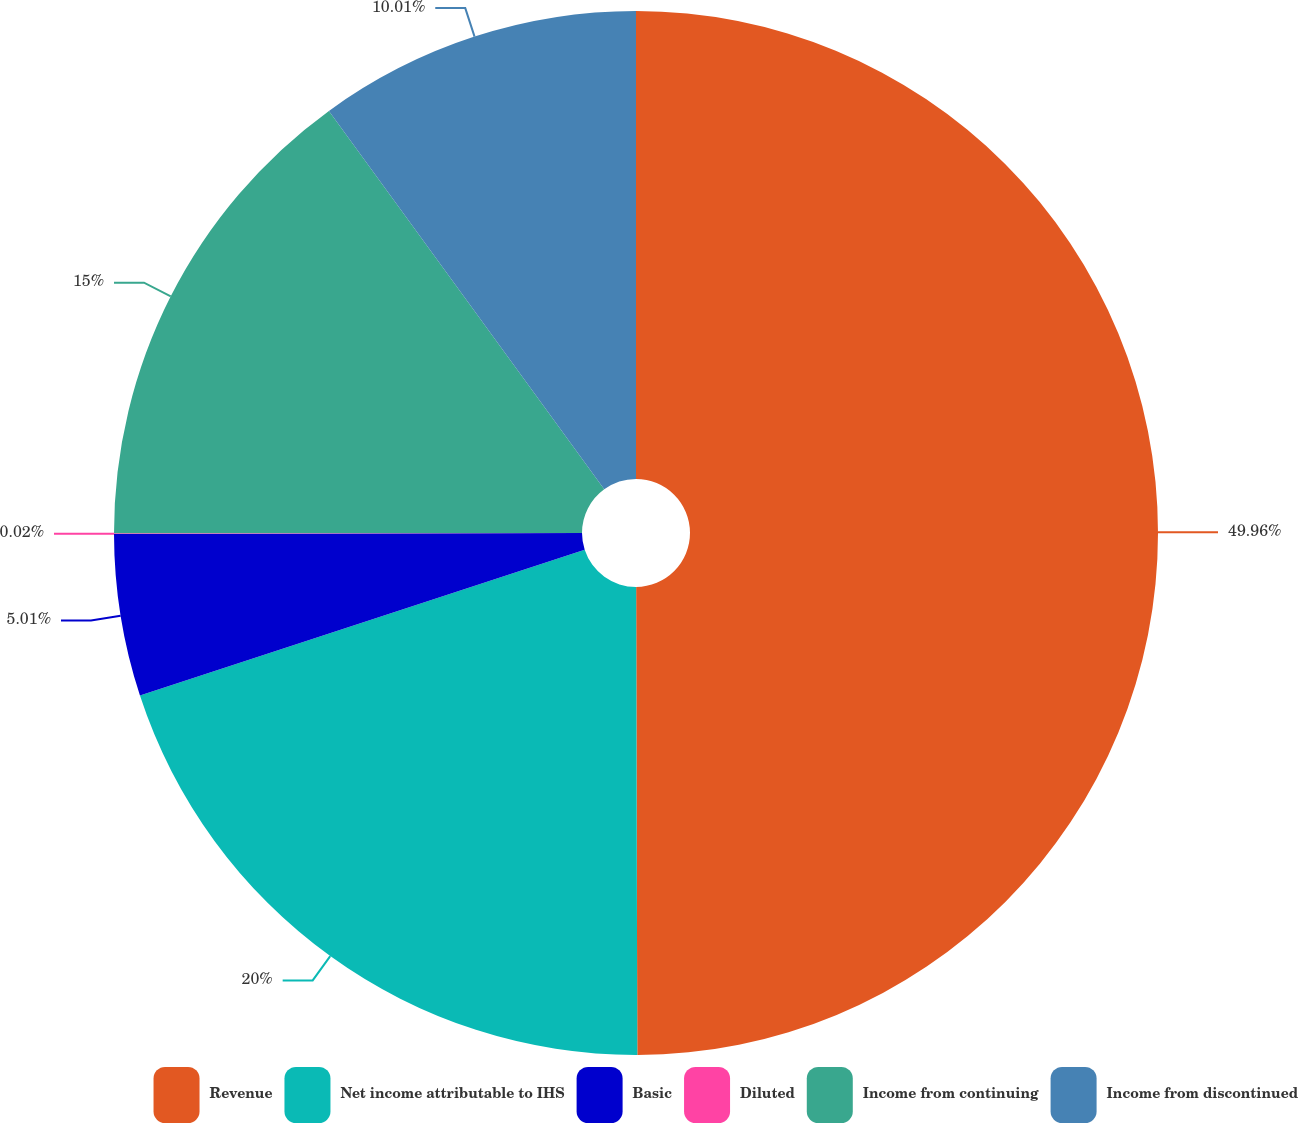Convert chart. <chart><loc_0><loc_0><loc_500><loc_500><pie_chart><fcel>Revenue<fcel>Net income attributable to IHS<fcel>Basic<fcel>Diluted<fcel>Income from continuing<fcel>Income from discontinued<nl><fcel>49.96%<fcel>20.0%<fcel>5.01%<fcel>0.02%<fcel>15.0%<fcel>10.01%<nl></chart> 